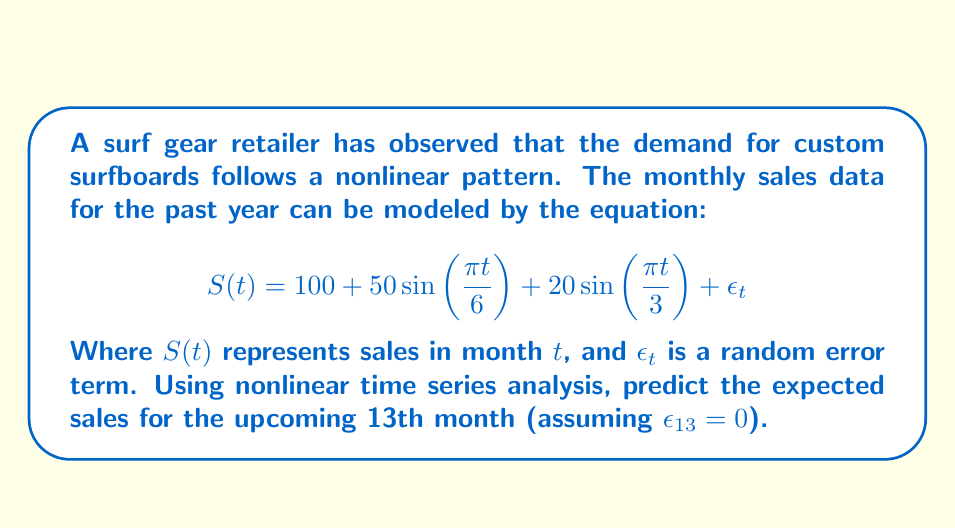Show me your answer to this math problem. To solve this problem, we need to follow these steps:

1. Understand the components of the equation:
   - $100$ is the baseline sales
   - $50\sin(\frac{\pi t}{6})$ represents a 12-month seasonal cycle
   - $20\sin(\frac{\pi t}{3})$ represents a 6-month seasonal cycle
   - $\epsilon_t$ is the random error term (given as 0 for month 13)

2. Substitute $t = 13$ into the equation:
   $$S(13) = 100 + 50\sin(\frac{\pi \cdot 13}{6}) + 20\sin(\frac{\pi \cdot 13}{3}) + 0$$

3. Simplify the arguments inside the sine functions:
   $$S(13) = 100 + 50\sin(\frac{13\pi}{6}) + 20\sin(\frac{13\pi}{3})$$

4. Calculate the values inside the sine functions:
   - $\frac{13\pi}{6} \approx 6.8068$ radians
   - $\frac{13\pi}{3} \approx 13.6136$ radians

5. Calculate the sine values:
   - $\sin(6.8068) \approx -0.4540$
   - $\sin(13.6136) \approx 0.9744$

6. Multiply the sine values by their respective coefficients:
   - $50 \cdot (-0.4540) = -22.70$
   - $20 \cdot 0.9744 = 19.488$

7. Sum all the components:
   $$S(13) = 100 + (-22.70) + 19.488 = 96.788$$

8. Round to the nearest whole number, as fractional surfboard sales are not practical:
   $$S(13) \approx 97$$
Answer: 97 surfboards 